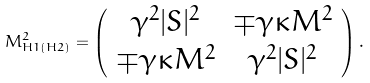Convert formula to latex. <formula><loc_0><loc_0><loc_500><loc_500>M _ { H 1 ( H 2 ) } ^ { 2 } = \left ( \begin{array} { c c } \gamma ^ { 2 } | S | ^ { 2 } & \mp \gamma \kappa M ^ { 2 } \\ \mp \gamma \kappa M ^ { 2 } & \gamma ^ { 2 } | S | ^ { 2 } \end{array} \right ) .</formula> 